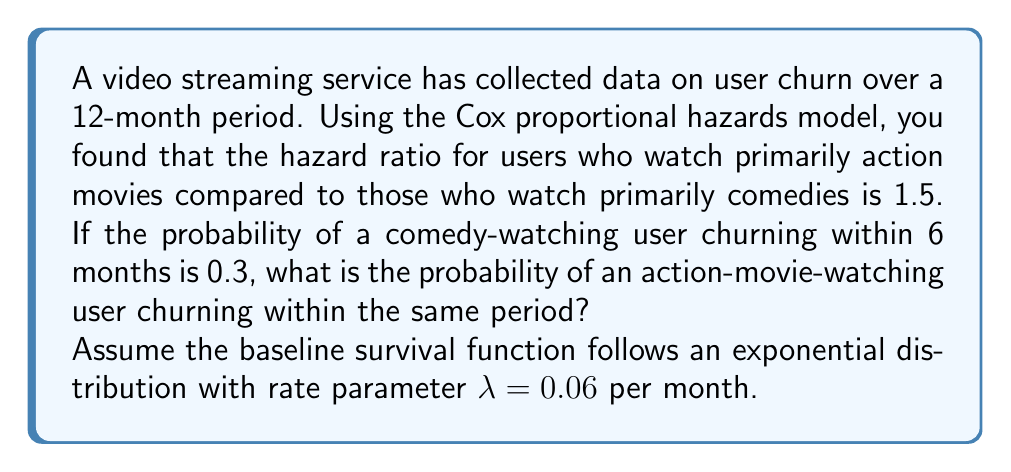Teach me how to tackle this problem. Let's approach this step-by-step:

1) The Cox proportional hazards model assumes that the hazard for an individual with covariates $X$ is:

   $h(t|X) = h_0(t) \exp(\beta X)$

   where $h_0(t)$ is the baseline hazard function.

2) The hazard ratio of 1.5 for action movie watchers compared to comedy watchers means:

   $\exp(\beta) = 1.5$

3) The baseline survival function for an exponential distribution is:

   $S_0(t) = \exp(-\lambda t)$

4) For comedy watchers (baseline group), the probability of churning within 6 months is 0.3:

   $1 - S_0(6) = 0.3$
   $S_0(6) = 0.7$

5) We can confirm that $\lambda = 0.06$ satisfies this:

   $S_0(6) = \exp(-0.06 * 6) \approx 0.7$

6) For action movie watchers, the survival function is:

   $S(t) = [S_0(t)]^{\exp(\beta)} = [S_0(t)]^{1.5}$

7) Therefore, the probability of an action movie watcher churning within 6 months is:

   $1 - S(6) = 1 - [S_0(6)]^{1.5} = 1 - 0.7^{1.5} \approx 0.4157$
Answer: 0.4157 